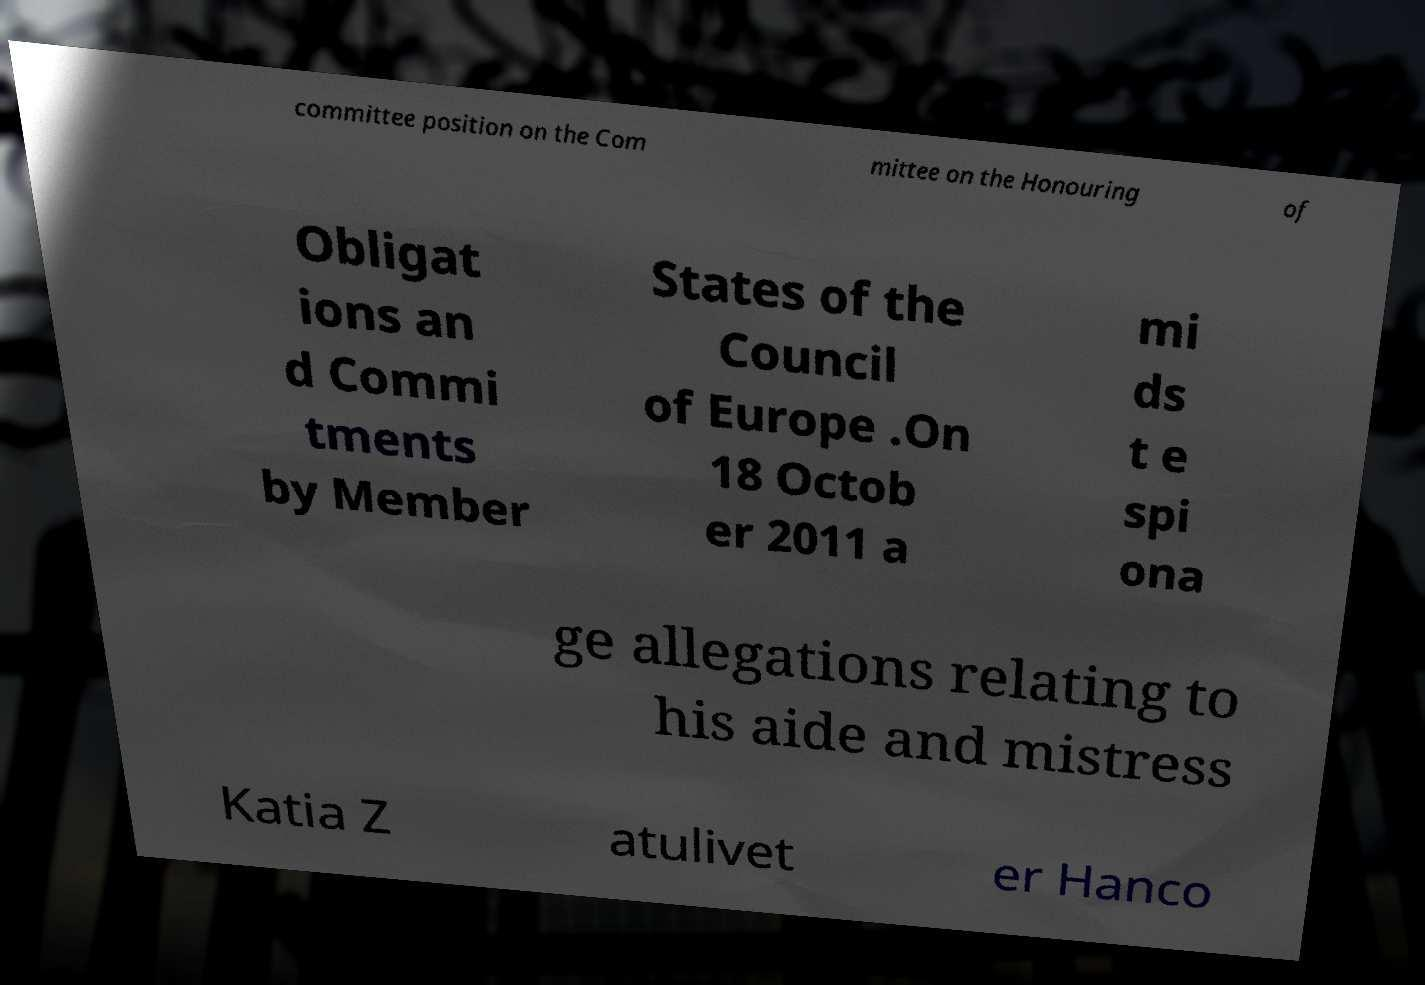Can you accurately transcribe the text from the provided image for me? committee position on the Com mittee on the Honouring of Obligat ions an d Commi tments by Member States of the Council of Europe .On 18 Octob er 2011 a mi ds t e spi ona ge allegations relating to his aide and mistress Katia Z atulivet er Hanco 